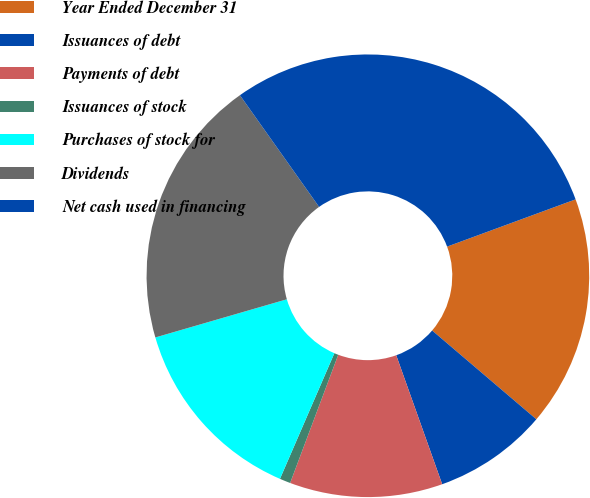<chart> <loc_0><loc_0><loc_500><loc_500><pie_chart><fcel>Year Ended December 31<fcel>Issuances of debt<fcel>Payments of debt<fcel>Issuances of stock<fcel>Purchases of stock for<fcel>Dividends<fcel>Net cash used in financing<nl><fcel>16.84%<fcel>8.32%<fcel>11.16%<fcel>0.79%<fcel>14.0%<fcel>19.68%<fcel>29.2%<nl></chart> 